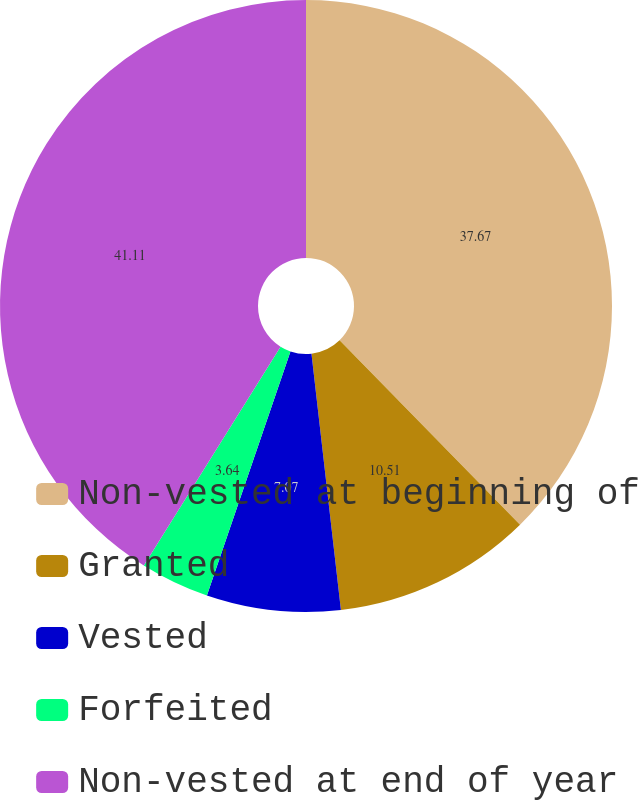Convert chart. <chart><loc_0><loc_0><loc_500><loc_500><pie_chart><fcel>Non-vested at beginning of<fcel>Granted<fcel>Vested<fcel>Forfeited<fcel>Non-vested at end of year<nl><fcel>37.67%<fcel>10.51%<fcel>7.07%<fcel>3.64%<fcel>41.11%<nl></chart> 